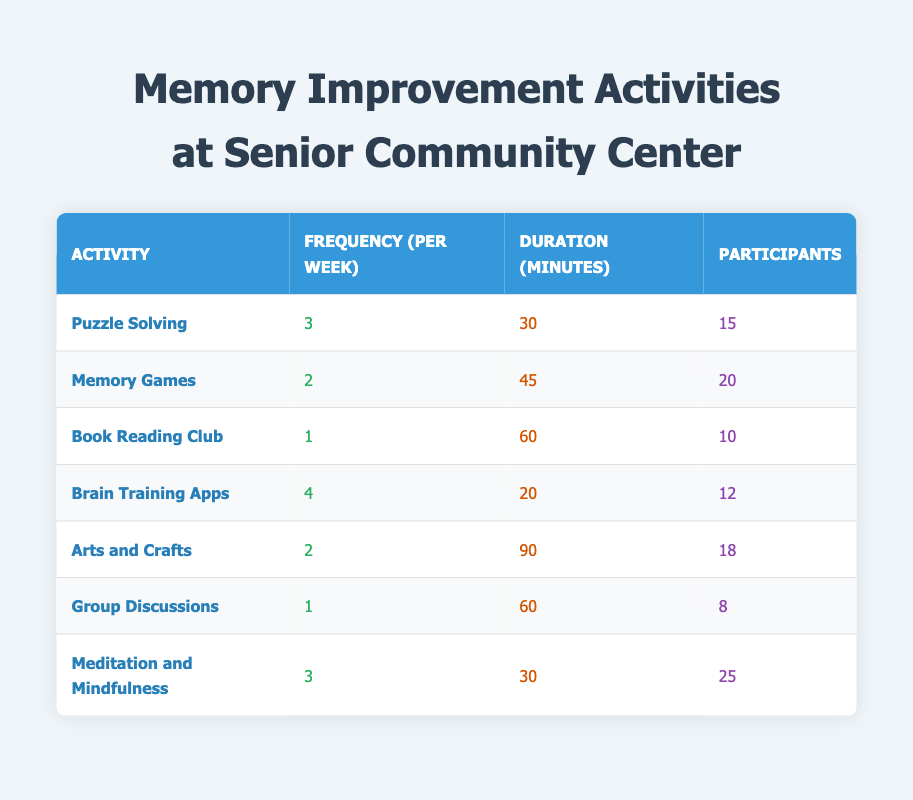What is the frequency per week of the “Puzzle Solving” activity? The table lists the frequency for “Puzzle Solving” as 3.
Answer: 3 How many participants are involved in “Memory Games”? The table indicates that 20 participants are involved in “Memory Games.”
Answer: 20 What is the total duration in minutes for “Brain Training Apps” per week? “Brain Training Apps” has a duration of 20 minutes per session and occurs 4 times a week, so total duration is 20 * 4 = 80 minutes.
Answer: 80 Which activity has the highest number of participants? The highest number of participants is 25 in “Meditation and Mindfulness,” according to the table.
Answer: 25 What is the average frequency of activities per week? To find the average, add all frequencies (3 + 2 + 1 + 4 + 2 + 1 + 3 = 16) and divide by the number of activities (7). This results in an average of 16 / 7 = approximately 2.29.
Answer: 2.29 Which activity occurs less than twice a week? The table shows “Book Reading Club” and “Group Discussions” both occur once a week, which is less than twice a week.
Answer: Yes Is the duration of “Arts and Crafts” longer than that of “Memory Games”? “Arts and Crafts” has a duration of 90 minutes while “Memory Games” has 45 minutes, making it longer.
Answer: Yes If a participant attends all activities, how much time would they spend per week? Adding up the total durations for each activity will give the overall time: (30*3 + 45*2 + 60*1 + 20*4 + 90*2 + 60*1 + 30*3) = 90 + 90 + 60 + 80 + 180 + 60 + 90 = 650 minutes.
Answer: 650 How many more participants are there in “Meditation and Mindfulness” than in “Group Discussions”? “Meditation and Mindfulness” has 25 participants and “Group Discussions” has 8. The difference is 25 - 8 = 17.
Answer: 17 